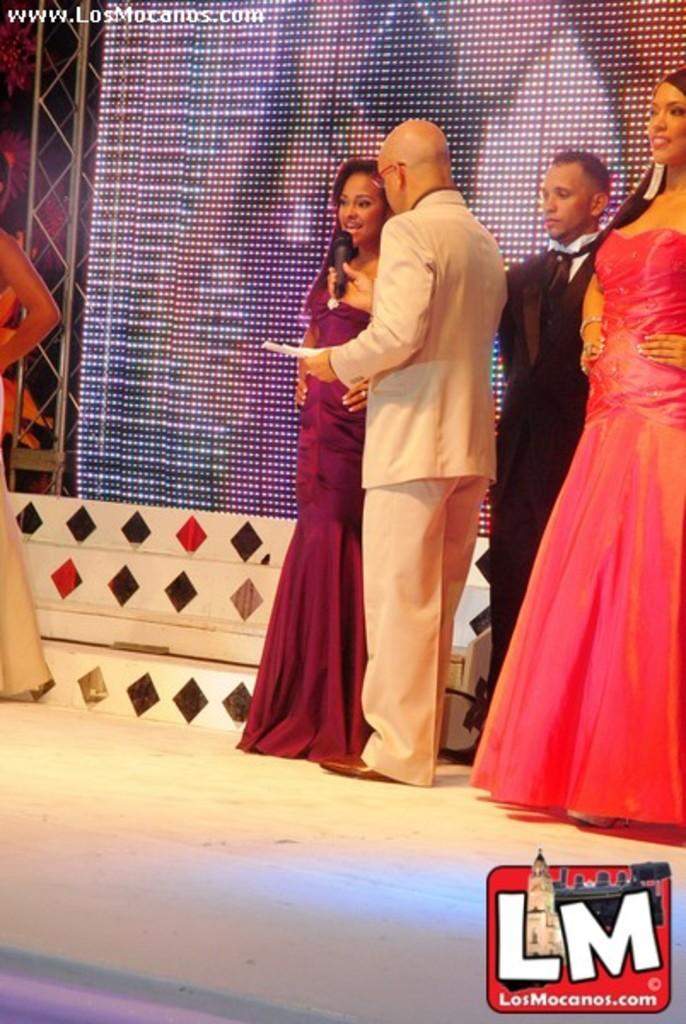What can be seen in the image that provides illumination? There are lights in the image. What type of structure is present in the image? There is a current pole in the image. Who is present in the image? There are people in the image. What is a man holding in the image? A man is holding a paper. What devices are present in the image for amplifying sound? Mics are present in the image. What type of plane is visible in the image? There is no plane present in the image. What date is marked on the calendar in the image? There is no calendar present in the image. 